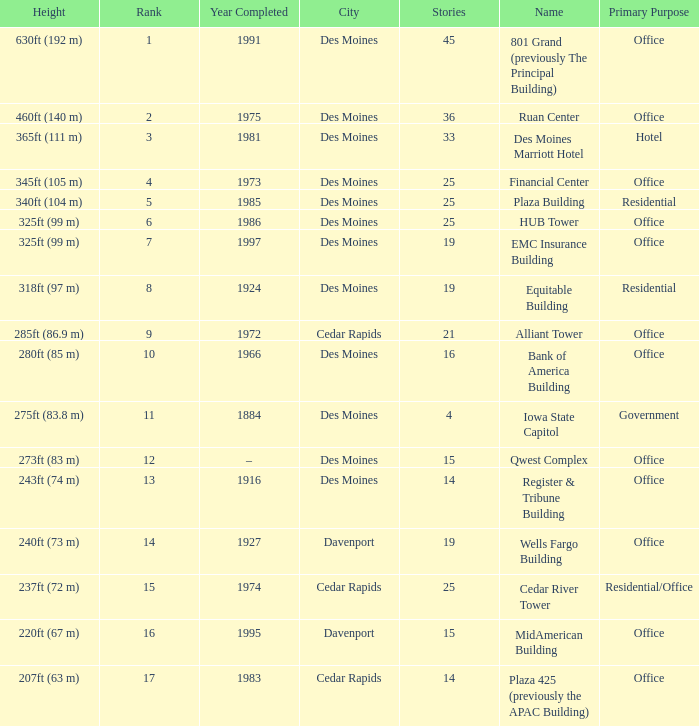What is the total stories that rank number 10? 1.0. 